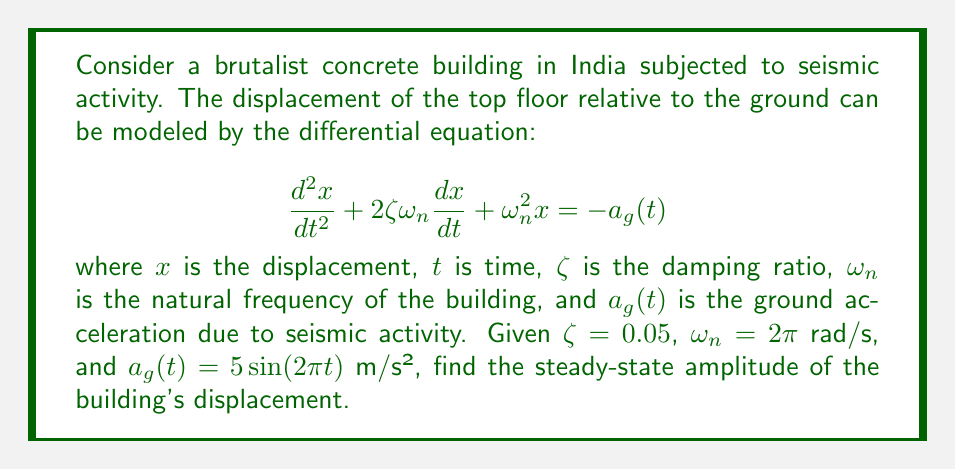Teach me how to tackle this problem. To solve this problem, we'll follow these steps:

1) The given differential equation represents a forced vibration system. For steady-state response to sinusoidal excitation, we can use the frequency response method.

2) The transfer function $H(\omega)$ for this system is:

   $$H(\omega) = \frac{1}{(\omega_n^2 - \omega^2) + 2i\zeta\omega_n\omega}$$

3) The magnitude of the transfer function is:

   $$|H(\omega)| = \frac{1}{\sqrt{(\omega_n^2 - \omega^2)^2 + (2\zeta\omega_n\omega)^2}}$$

4) In our case, $\omega = 2\pi$ rad/s (same as $\omega_n$), so we can simplify:

   $$|H(\omega_n)| = \frac{1}{\omega_n^2\sqrt{(2\zeta)^2}} = \frac{1}{2\zeta\omega_n^2}$$

5) Substituting the given values:

   $$|H(\omega_n)| = \frac{1}{2 \cdot 0.05 \cdot (2\pi)^2} = \frac{1}{0.1 \cdot 4\pi^2} \approx 0.7958$$

6) The steady-state amplitude is the product of $|H(\omega_n)|$ and the amplitude of $a_g(t)$:

   Amplitude = $0.7958 \cdot 5 \approx 3.979$ m

Therefore, the steady-state amplitude of the building's displacement is approximately 3.979 meters.
Answer: 3.979 m 